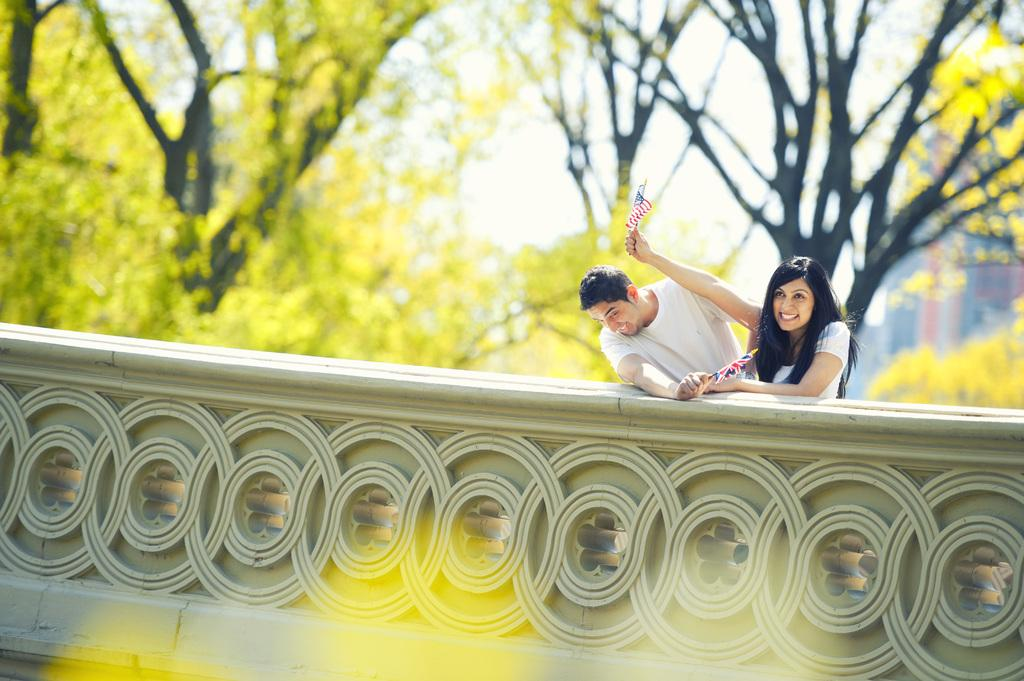How many people are present in the image? There are two people in the image, a man and a woman. What are the man and woman wearing? Both the man and woman are wearing white dresses. What are the man and woman holding in their hands? The man and woman are holding flags in their hands. What can be seen in the background of the image? There are trees and the sky is visible in the background of the image. What type of bag is the man carrying on his finger in the image? There is no bag present in the image, and the man is not carrying anything on his finger. 